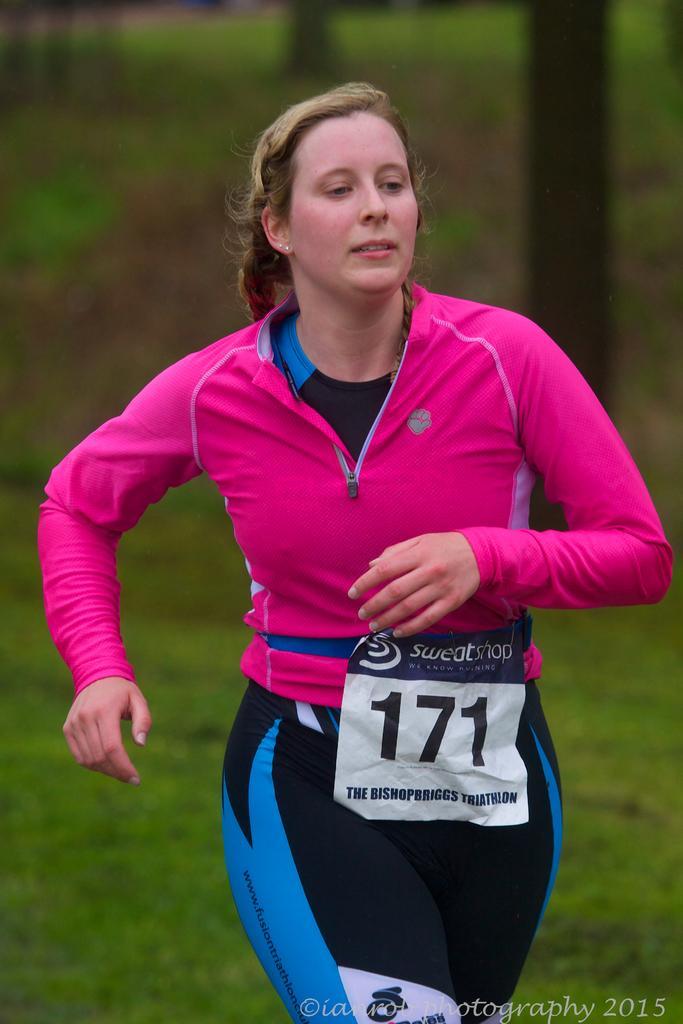In one or two sentences, can you explain what this image depicts? In the picture we can see a woman. There is a blur background with greenery. 